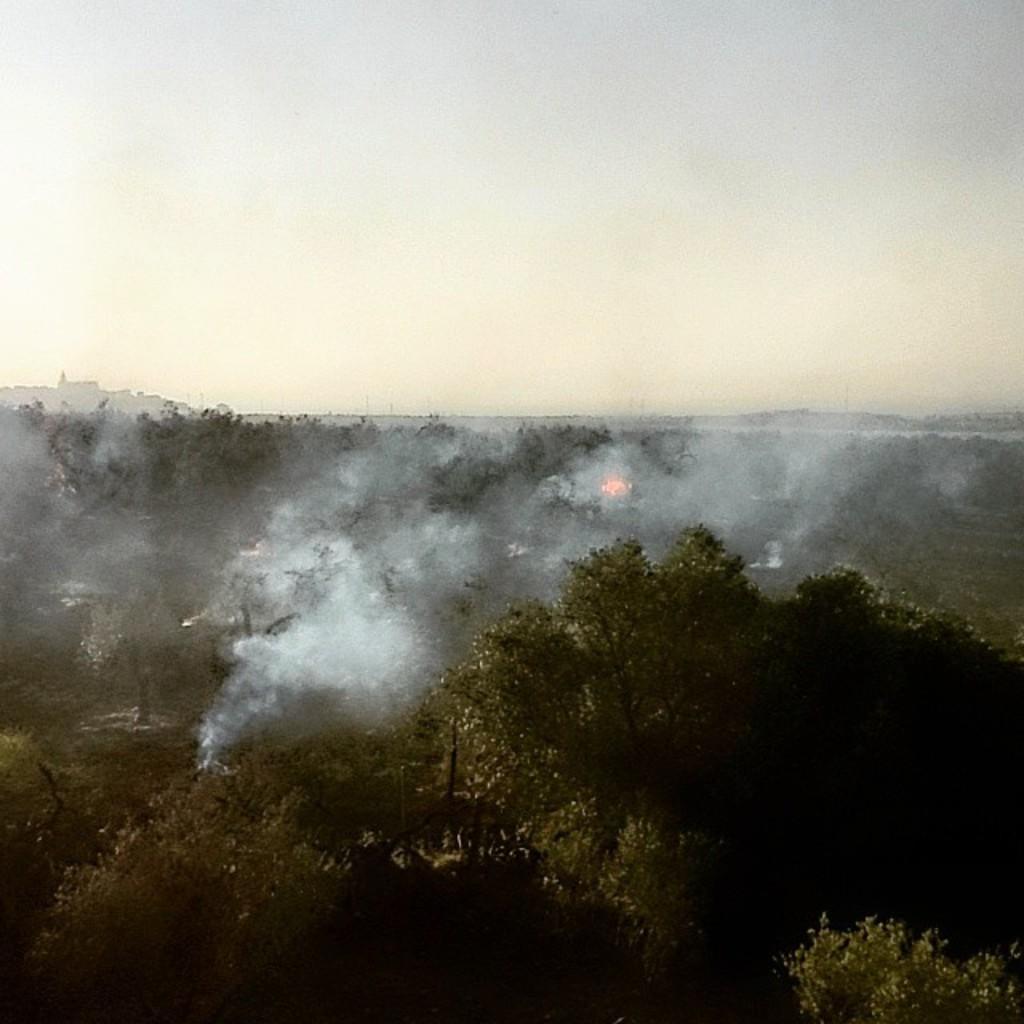Please provide a concise description of this image. In this image there are trees and there is a smoke coming out of the trees which are in the center. 